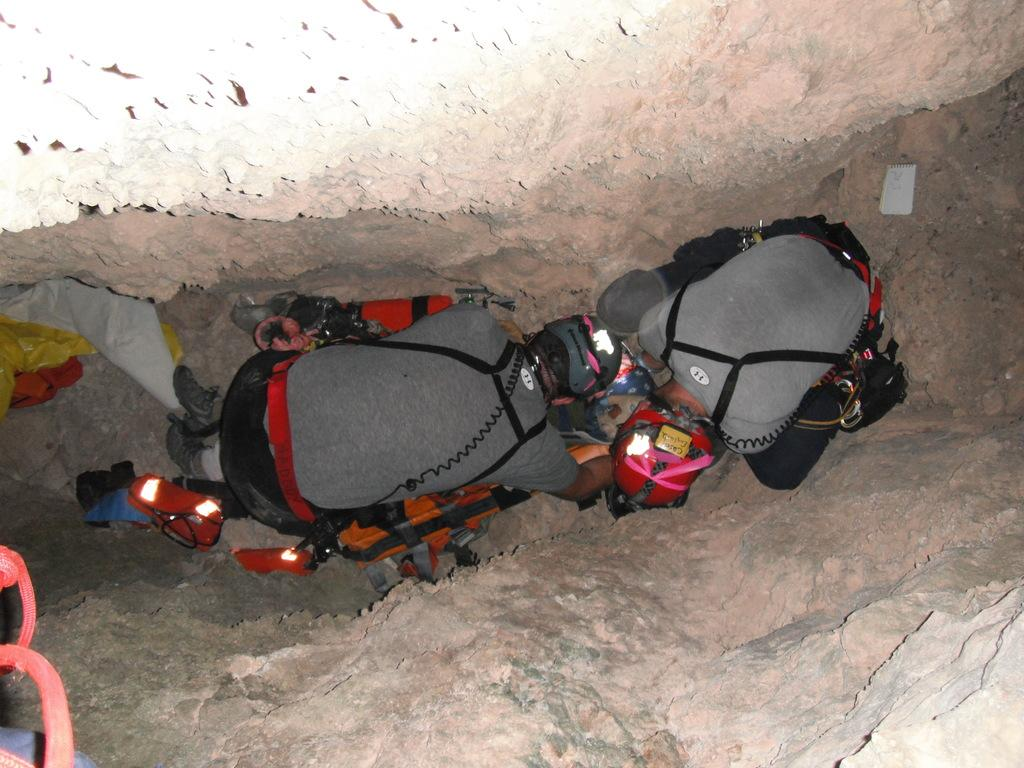How many people are in the image? There are two people in the image. Where are the people located in the image? The people are on the ground. What items can be seen near the people? There are shoes, a bag, an extinguisher, and unspecified objects placed beside the people. What type of surface can be seen in the image? There are rocks in the image. What type of sign can be seen in the image? There is no sign present in the image. What material is the hydrant made of in the image? There is no hydrant present in the image. 